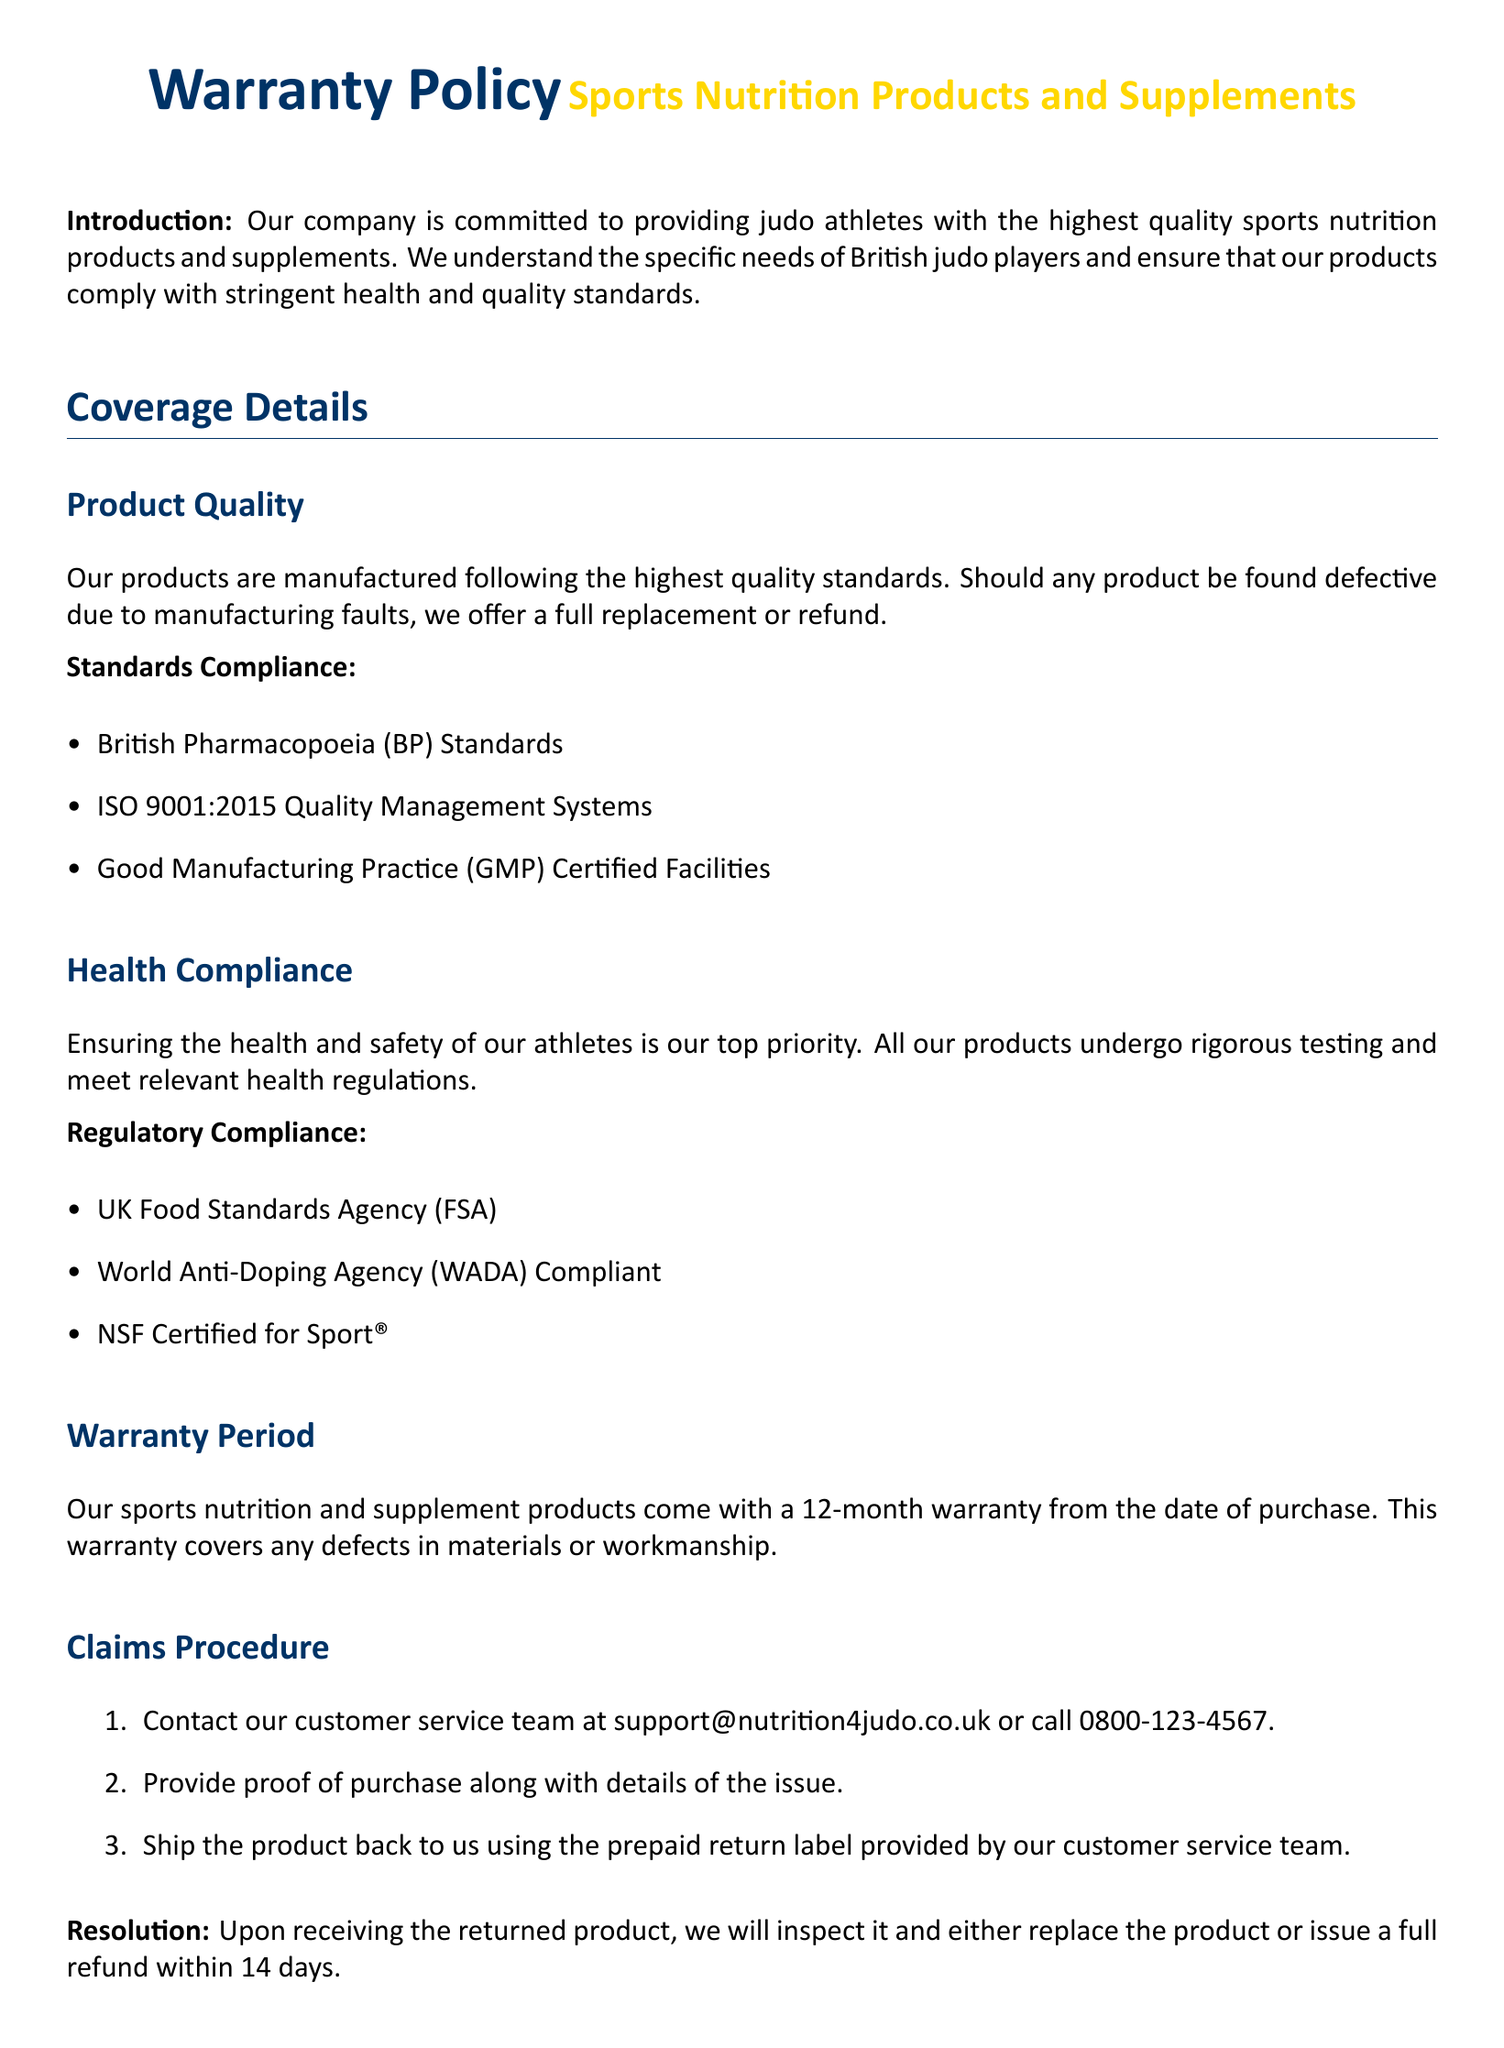what is the warranty period for the products? The warranty period for the products is stated in the document, mentioning the duration from the date of purchase.
Answer: 12 months which facility certification is mentioned in the warranty? The document specifies the type of certification that ensures high-quality manufacturing processes.
Answer: GMP Certified Facilities what should a customer provide to claim the warranty? The warranty claims procedure specifies what must be submitted by the customer when they contact customer service.
Answer: proof of purchase which agency's standards does the product adhere to regarding health? The document lists regulatory compliance that the products meet, particularly those related to health safety standards.
Answer: UK Food Standards Agency how long will it take to process a refund after receiving a returned product? The document provides information on the timeline for resolution of warranty claims, including refunds.
Answer: 14 days what type of damages are excluded from the warranty? The document outlines specific scenarios under which the warranty does not apply, indicating various misuse situations.
Answer: improper use what is the email address for customer service? The contact information includes an email address for customer inquiries and support.
Answer: support@nutrition4judo.co.uk which organization's compliance is mentioned to ensure anti-doping regulations? The document emphasizes the importance of adhering to specific regulation bodies related to sports compliance.
Answer: World Anti-Doping Agency 